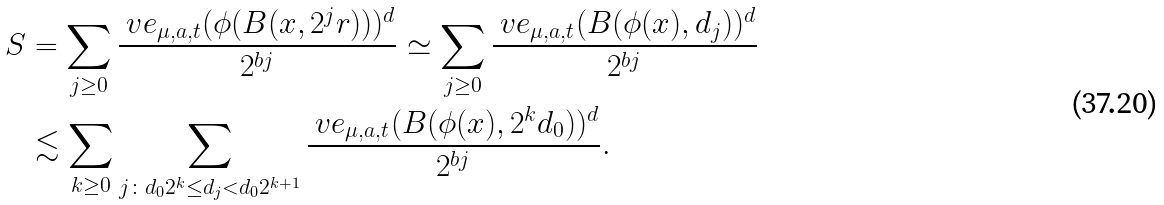<formula> <loc_0><loc_0><loc_500><loc_500>S & = \sum _ { j \geq 0 } \frac { \ v e _ { \mu , a , t } ( \phi ( B ( x , 2 ^ { j } r ) ) ) ^ { d } } { 2 ^ { b j } } \simeq \sum _ { j \geq 0 } \frac { \ v e _ { \mu , a , t } ( B ( \phi ( x ) , d _ { j } ) ) ^ { d } } { 2 ^ { b j } } \\ & \lesssim \sum _ { k \geq 0 } \sum _ { j \colon d _ { 0 } 2 ^ { k } \leq d _ { j } < d _ { 0 } 2 ^ { k + 1 } } \frac { \ v e _ { \mu , a , t } ( B ( \phi ( x ) , 2 ^ { k } d _ { 0 } ) ) ^ { d } } { 2 ^ { b j } } .</formula> 